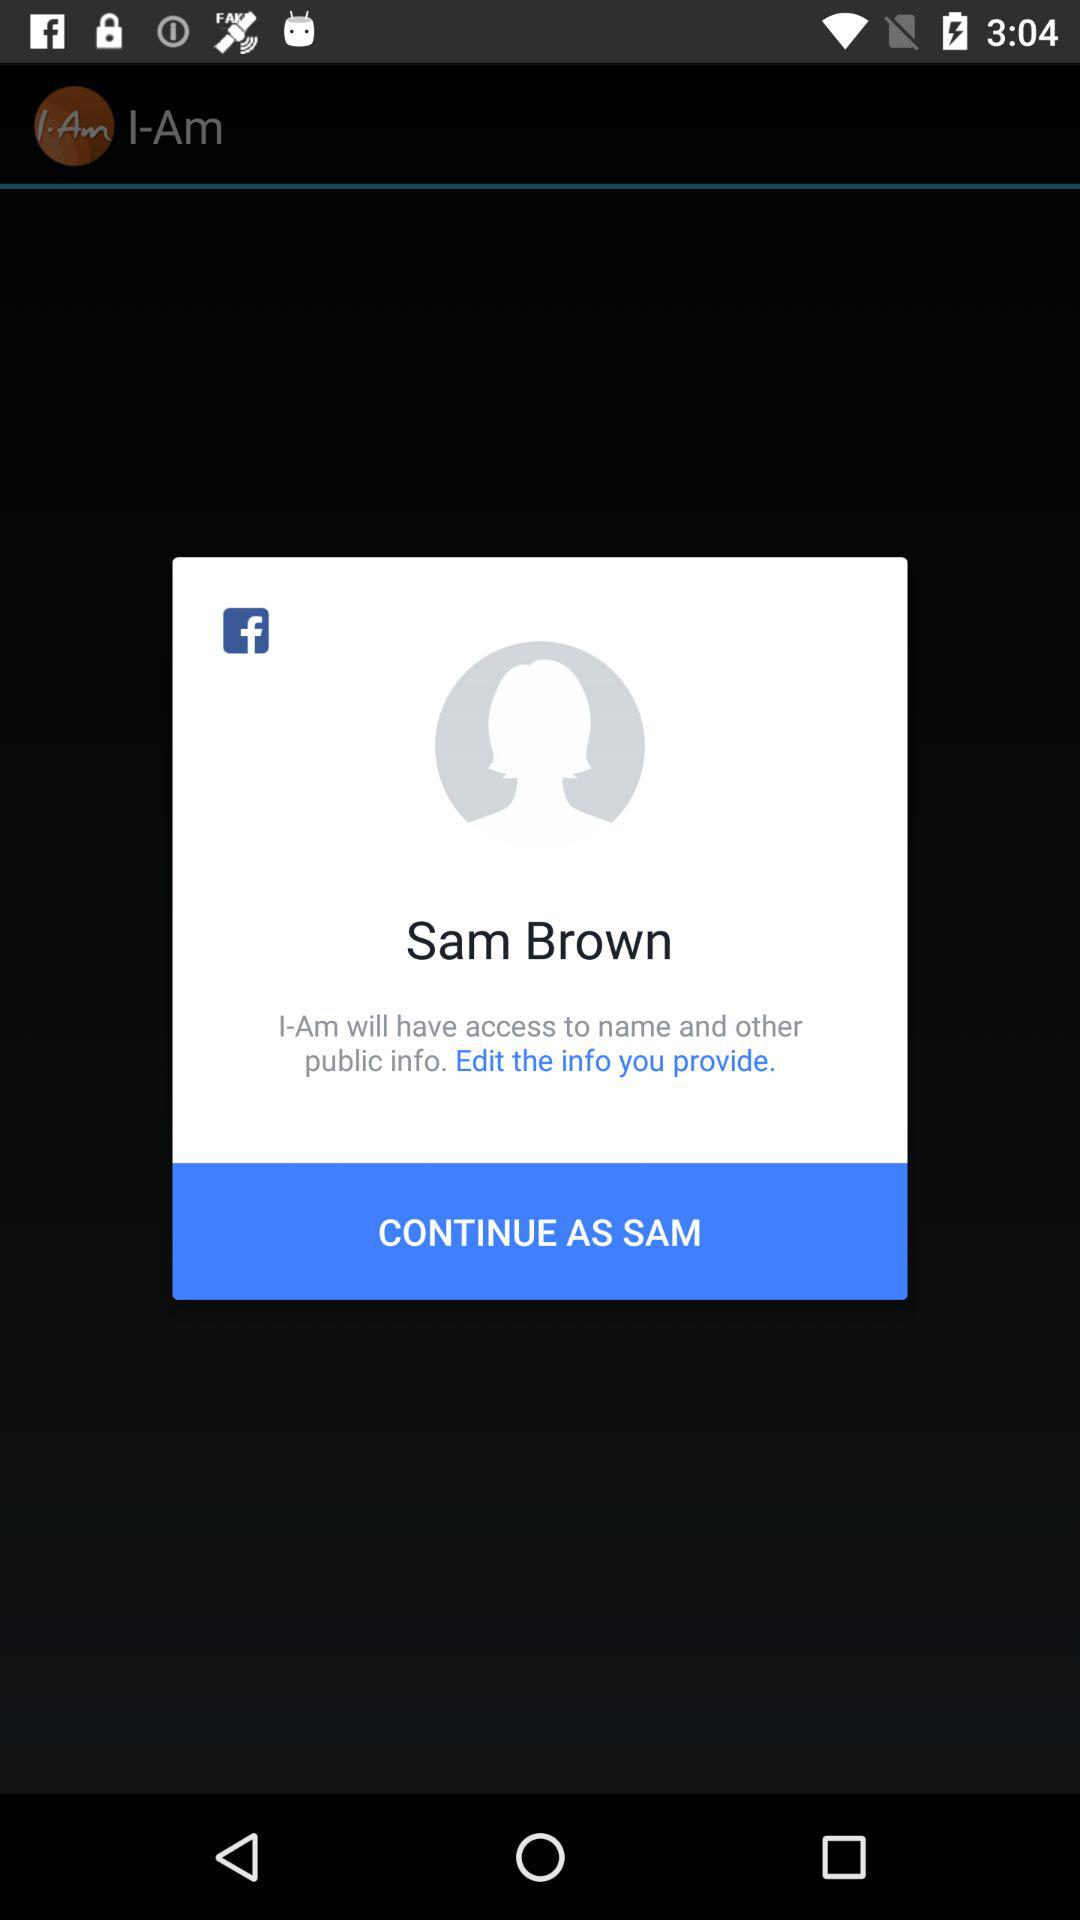What is the user name? The user name is Sam Brown. 